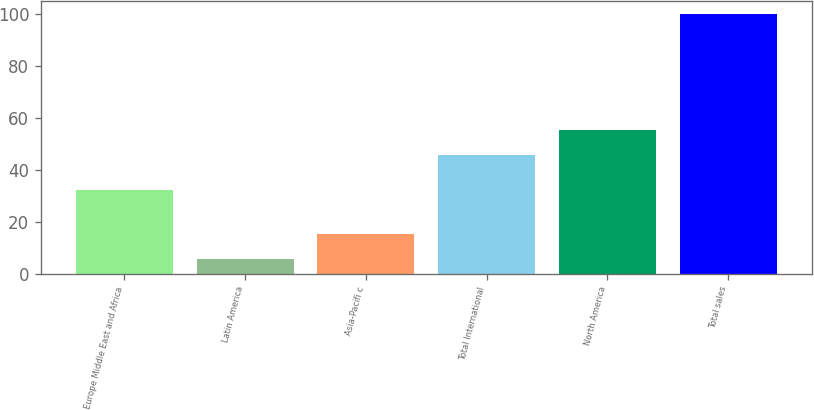Convert chart. <chart><loc_0><loc_0><loc_500><loc_500><bar_chart><fcel>Europe Middle East and Africa<fcel>Latin America<fcel>Asia-Pacifi c<fcel>Total International<fcel>North America<fcel>Total sales<nl><fcel>32.2<fcel>5.7<fcel>15.13<fcel>45.8<fcel>55.23<fcel>100<nl></chart> 